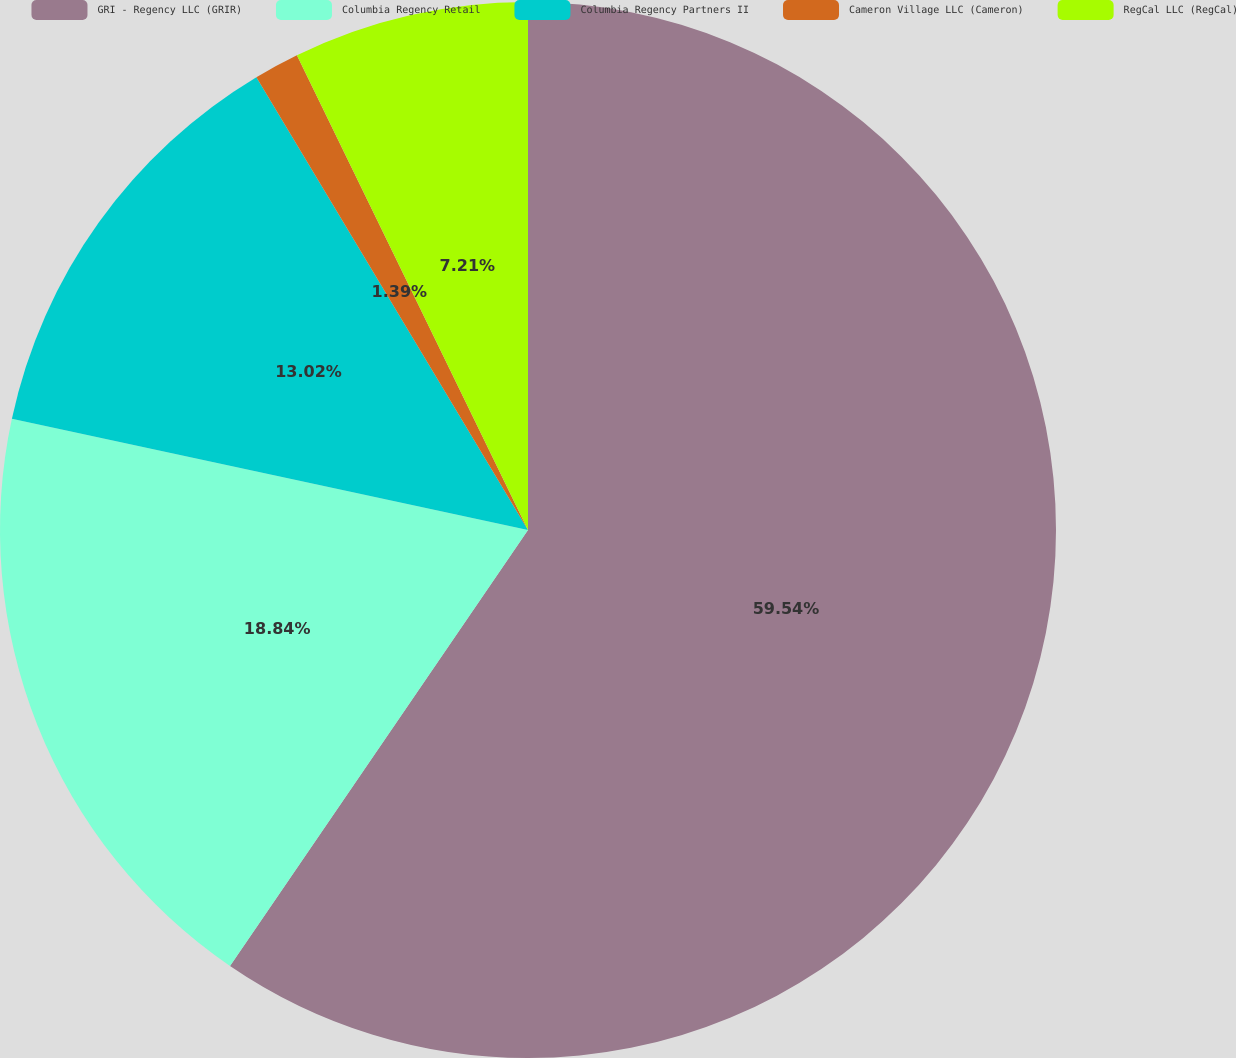Convert chart. <chart><loc_0><loc_0><loc_500><loc_500><pie_chart><fcel>GRI - Regency LLC (GRIR)<fcel>Columbia Regency Retail<fcel>Columbia Regency Partners II<fcel>Cameron Village LLC (Cameron)<fcel>RegCal LLC (RegCal)<nl><fcel>59.55%<fcel>18.84%<fcel>13.02%<fcel>1.39%<fcel>7.21%<nl></chart> 